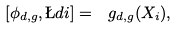<formula> <loc_0><loc_0><loc_500><loc_500>\left [ \phi _ { d , g } , \L d i \right ] = \ g _ { d , g } ( X _ { i } ) ,</formula> 